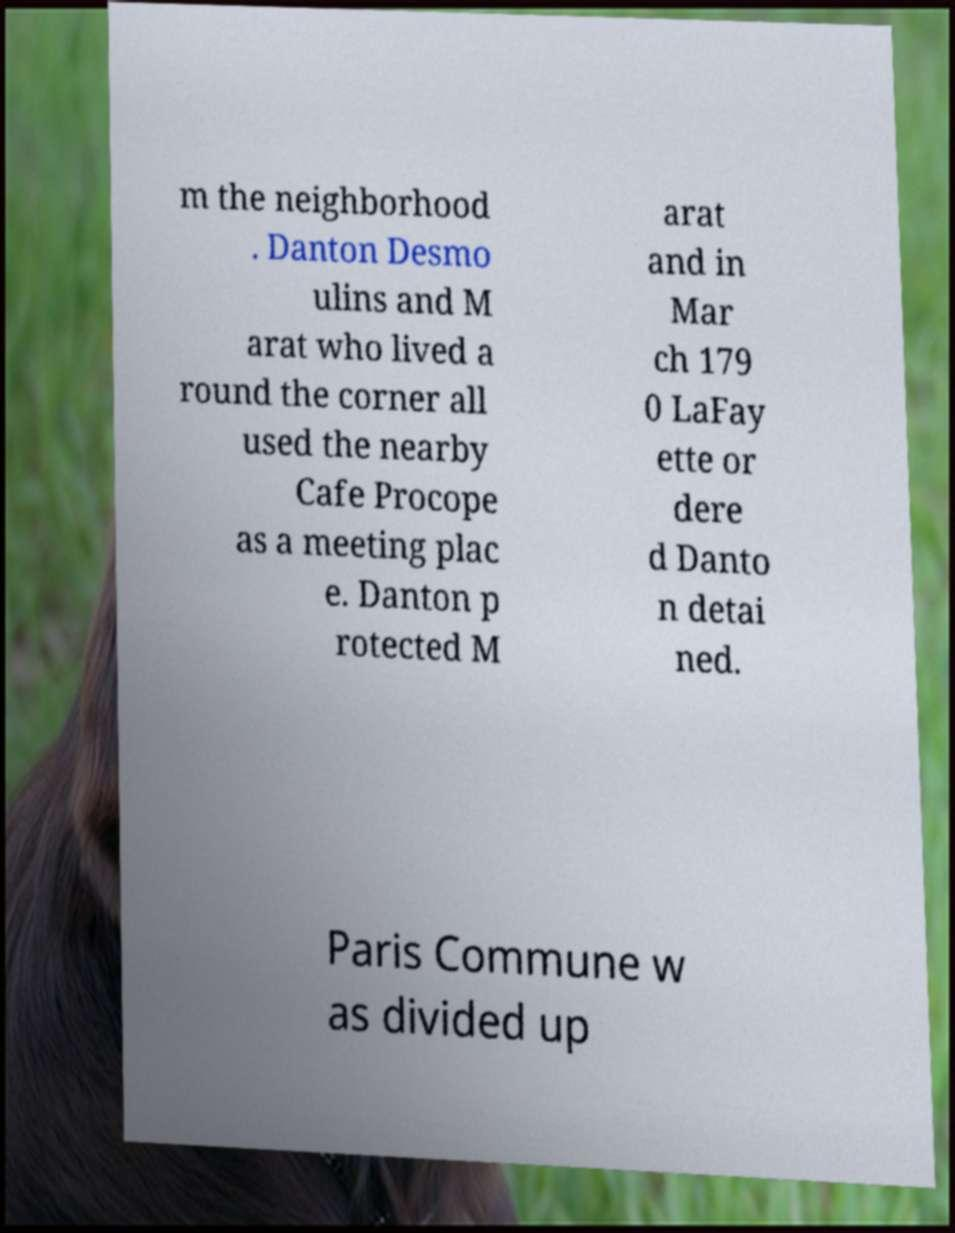Could you assist in decoding the text presented in this image and type it out clearly? m the neighborhood . Danton Desmo ulins and M arat who lived a round the corner all used the nearby Cafe Procope as a meeting plac e. Danton p rotected M arat and in Mar ch 179 0 LaFay ette or dere d Danto n detai ned. Paris Commune w as divided up 